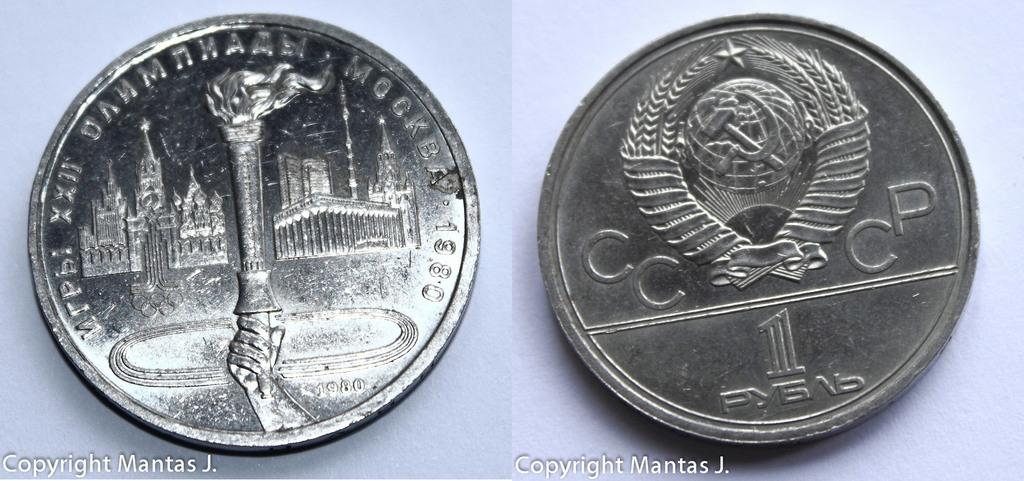<image>
Write a terse but informative summary of the picture. A silver colored coin from the CCCP dated 1980. 